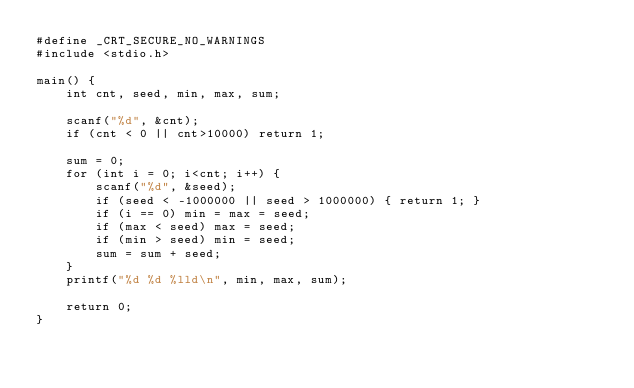Convert code to text. <code><loc_0><loc_0><loc_500><loc_500><_C_>#define _CRT_SECURE_NO_WARNINGS 
#include <stdio.h>

main() {
	int cnt, seed, min, max, sum;

	scanf("%d", &cnt);
	if (cnt < 0 || cnt>10000) return 1;

	sum = 0;
	for (int i = 0; i<cnt; i++) {
		scanf("%d", &seed);
		if (seed < -1000000 || seed > 1000000) { return 1; }
		if (i == 0) min = max = seed;
		if (max < seed) max = seed;
		if (min > seed) min = seed;
		sum = sum + seed;
	}
	printf("%d %d %lld\n", min, max, sum);

	return 0;
}
</code> 